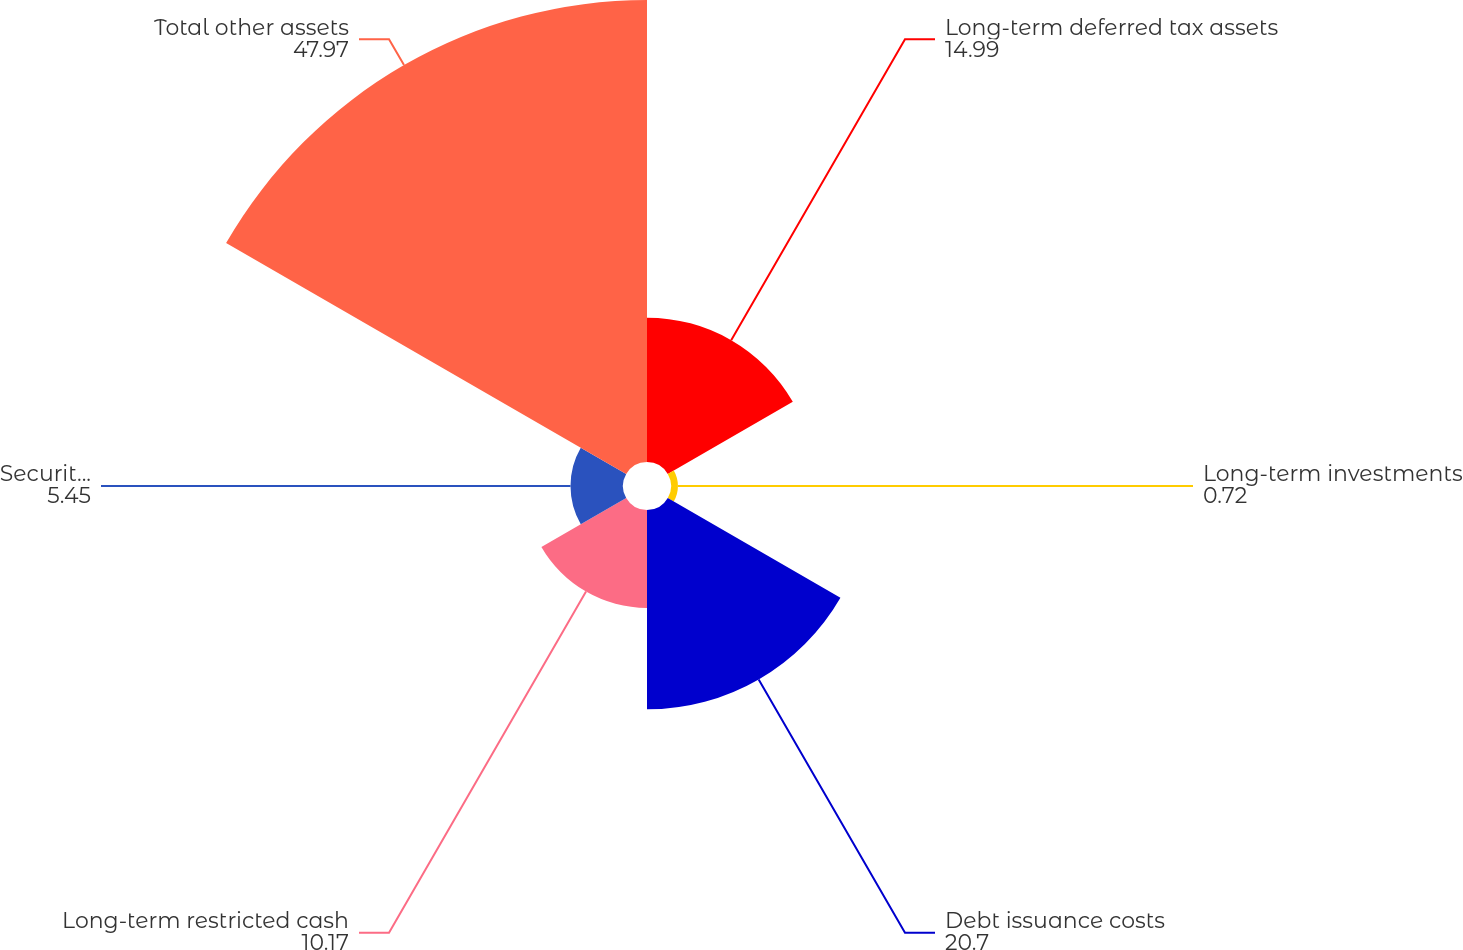Convert chart. <chart><loc_0><loc_0><loc_500><loc_500><pie_chart><fcel>Long-term deferred tax assets<fcel>Long-term investments<fcel>Debt issuance costs<fcel>Long-term restricted cash<fcel>Security deposits and other<fcel>Total other assets<nl><fcel>14.99%<fcel>0.72%<fcel>20.7%<fcel>10.17%<fcel>5.45%<fcel>47.97%<nl></chart> 